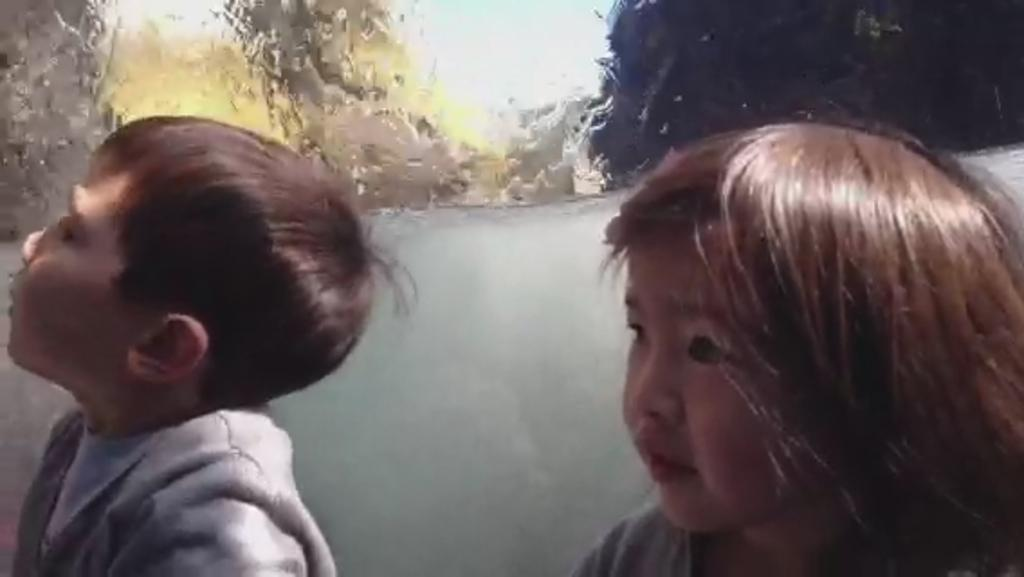How many kids are in the foreground of the picture? There are two kids in the foreground of the picture. What can be seen in the background of the picture? There is a painting visible in the background of the picture. What suggestion does the achiever make in the picture? There is no achiever present in the picture, and therefore no suggestion can be attributed to them. 